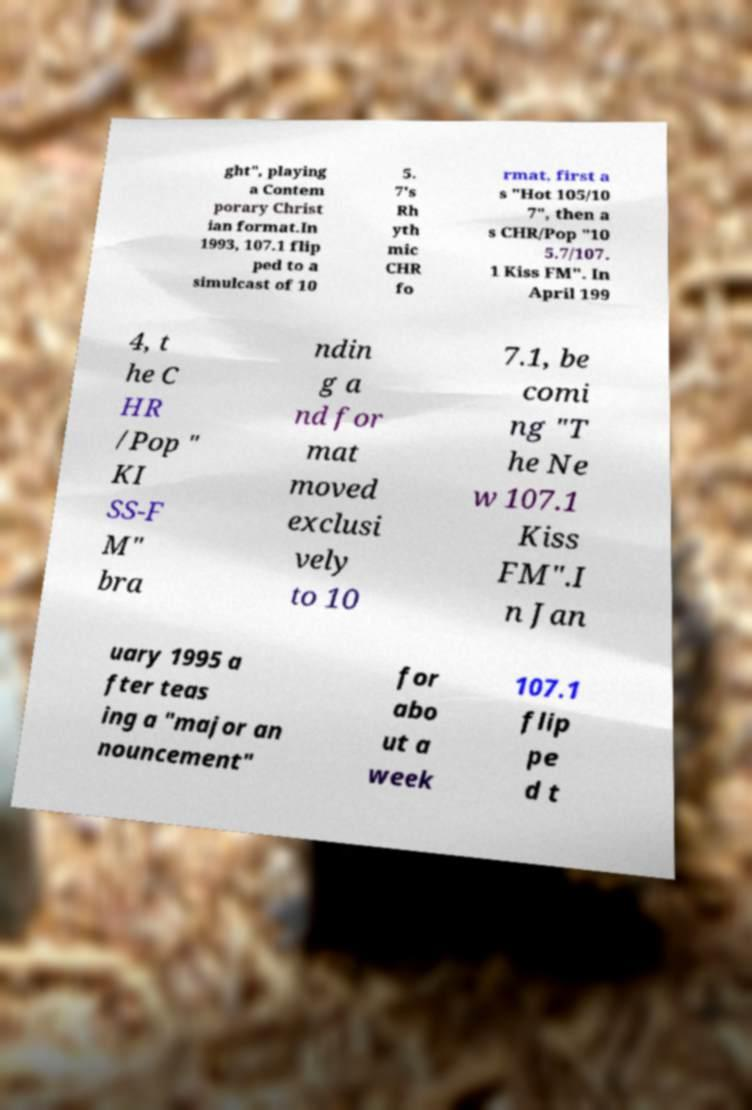For documentation purposes, I need the text within this image transcribed. Could you provide that? ght", playing a Contem porary Christ ian format.In 1993, 107.1 flip ped to a simulcast of 10 5. 7's Rh yth mic CHR fo rmat, first a s "Hot 105/10 7", then a s CHR/Pop "10 5.7/107. 1 Kiss FM". In April 199 4, t he C HR /Pop " KI SS-F M" bra ndin g a nd for mat moved exclusi vely to 10 7.1, be comi ng "T he Ne w 107.1 Kiss FM".I n Jan uary 1995 a fter teas ing a "major an nouncement" for abo ut a week 107.1 flip pe d t 